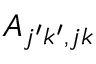<formula> <loc_0><loc_0><loc_500><loc_500>A _ { j ^ { \prime } k ^ { \prime } , j k }</formula> 